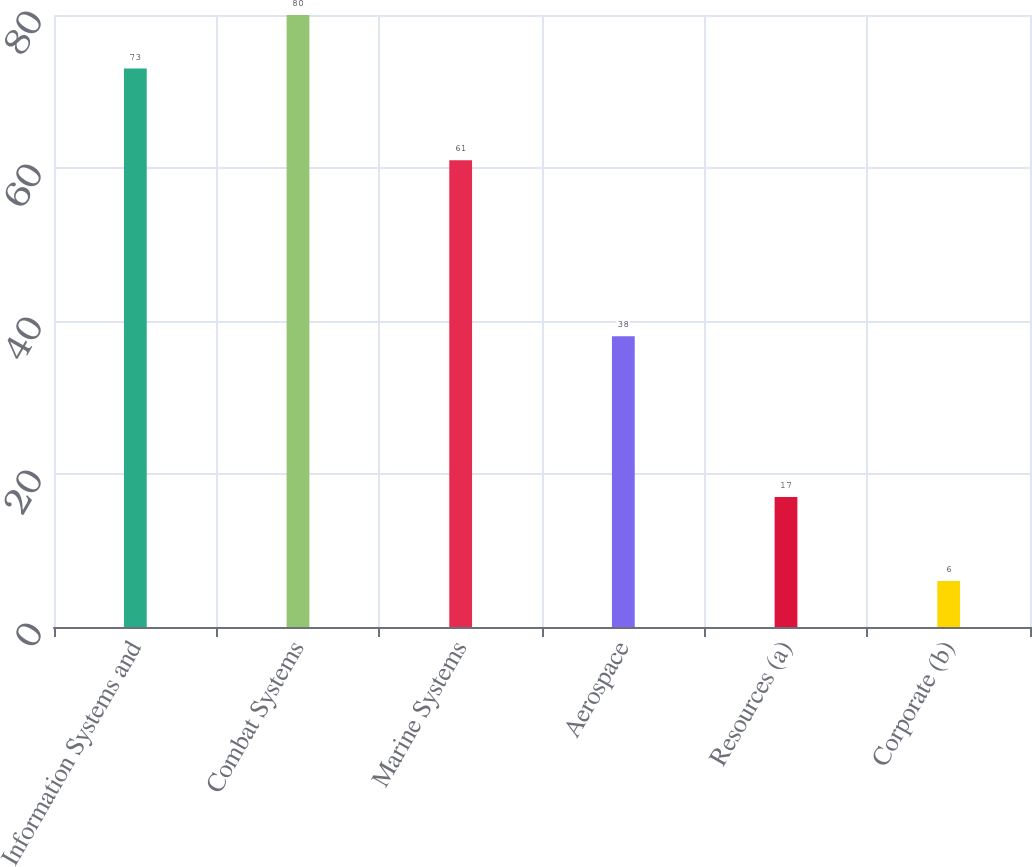Convert chart. <chart><loc_0><loc_0><loc_500><loc_500><bar_chart><fcel>Information Systems and<fcel>Combat Systems<fcel>Marine Systems<fcel>Aerospace<fcel>Resources (a)<fcel>Corporate (b)<nl><fcel>73<fcel>80<fcel>61<fcel>38<fcel>17<fcel>6<nl></chart> 